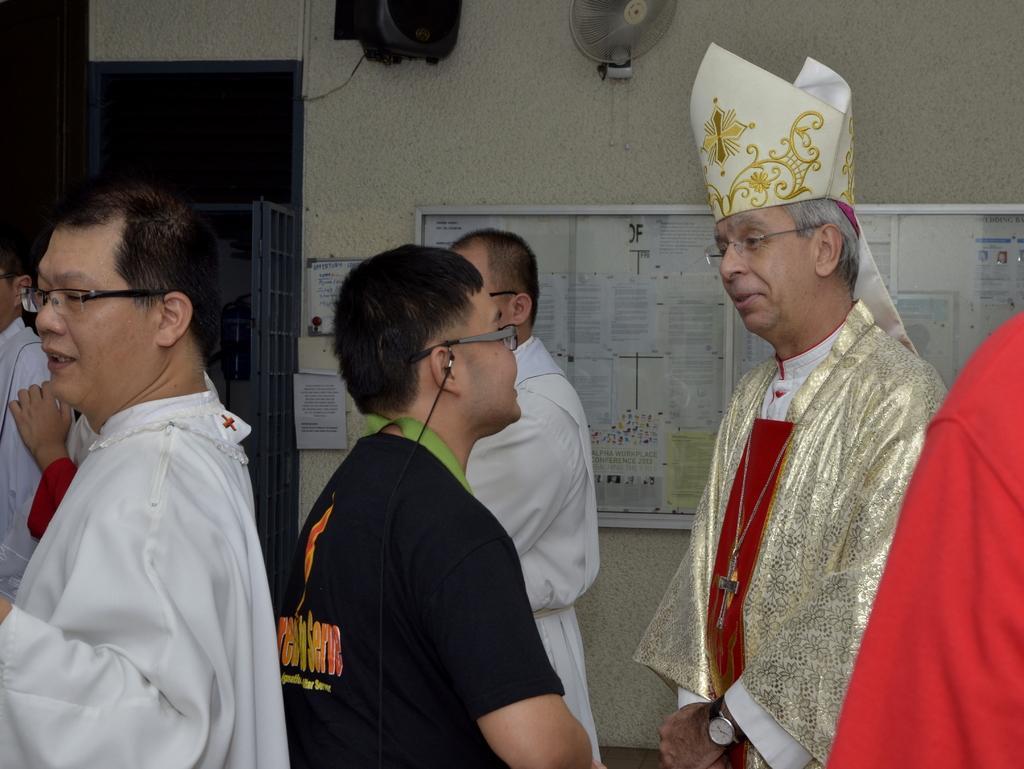Can you describe this image briefly? In this picture there are group of people standing. At the back there are papers on the board and on the wall. At the top there is a fan and light on the wall. On the left side of the image there is a metal door and there is a fire extinguisher. 